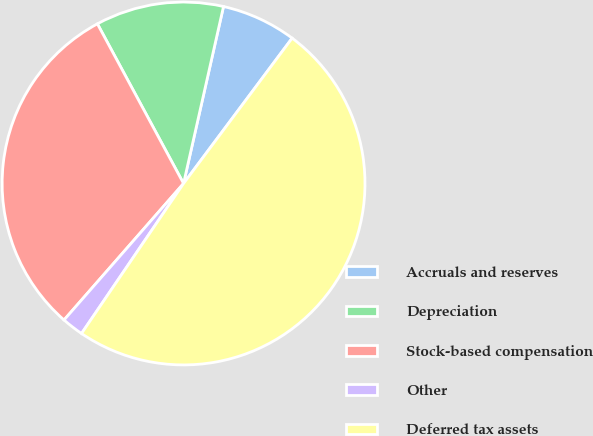Convert chart to OTSL. <chart><loc_0><loc_0><loc_500><loc_500><pie_chart><fcel>Accruals and reserves<fcel>Depreciation<fcel>Stock-based compensation<fcel>Other<fcel>Deferred tax assets<nl><fcel>6.68%<fcel>11.41%<fcel>30.68%<fcel>1.94%<fcel>49.3%<nl></chart> 